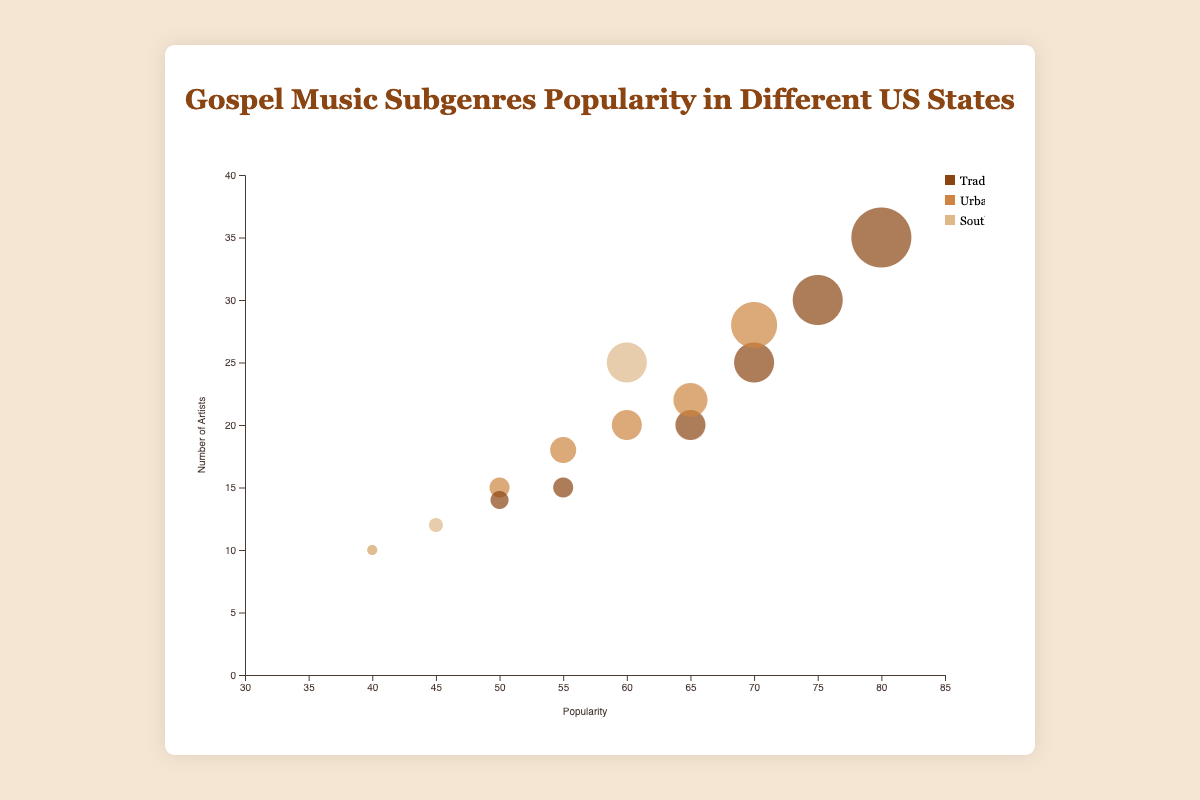What's the title of the chart? The title is written at the top of the chart and reads "Gospel Music Subgenres Popularity in Different US States".
Answer: Gospel Music Subgenres Popularity in Different US States What are the x and y axes representing in this chart? The x-axis at the bottom represents Popularity and the y-axis on the left represents the Number of Artists.
Answer: Popularity, Number of Artists Which state has the highest number of artists in Traditional Gospel? Look at the position of the circles labeled "Traditional Gospel". The highest circle on the y-axis is for Tennessee.
Answer: Tennessee What's the popularity of Traditional Gospel in Missouri? Find the circle that represents Missouri and Traditional Gospel. The x-axis value for this circle is 65.
Answer: 65 How many states have at least one Gospel Subgenre with a popularity of 70 or higher? Identify the number of distinct states with at least one circle positioned at or above a Popularity of 70 on the x-axis. They are Texas, Georgia, Tennessee, and New York.
Answer: 4 Which subgenre has the highest popularity in Tennessee? Look for circles corresponding to Tennessee and compare their positions on the x-axis. The "Traditional Gospel" circle is the furthest right at 80.
Answer: Traditional Gospel Compare the popularity of Urban Contemporary Gospel in California and Georgia. Check the positions of the circles for Urban Contemporary Gospel in both states on the x-axis. California is at 65, whereas Georgia is at 55.
Answer: California Which subgenre has the largest bubble size in Georgia? Compare the bubble sizes within Georgia. The largest bubble, representing the most artists, is Traditional Gospel.
Answer: Traditional Gospel What is the average popularity of Southern Gospel across all states? Sum the popularity values for Southern Gospel (40 + 45 + 60 + 40) and divide by the number of entries (4). (40+45+60+40)/4 = 46.25
Answer: 46.25 